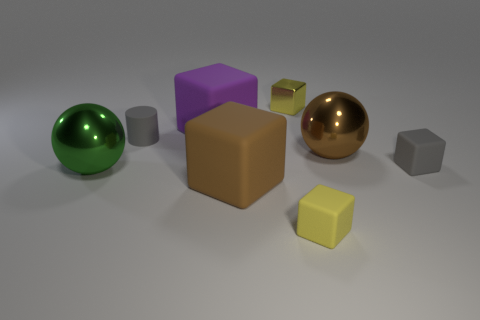Subtract all gray cubes. How many cubes are left? 4 Subtract all gray balls. How many yellow blocks are left? 2 Add 1 small gray matte cylinders. How many objects exist? 9 Subtract all brown cubes. How many cubes are left? 4 Subtract all spheres. How many objects are left? 6 Subtract 2 blocks. How many blocks are left? 3 Subtract all brown blocks. Subtract all green cylinders. How many blocks are left? 4 Subtract all yellow rubber things. Subtract all tiny gray matte blocks. How many objects are left? 6 Add 2 purple rubber cubes. How many purple rubber cubes are left? 3 Add 6 large green shiny spheres. How many large green shiny spheres exist? 7 